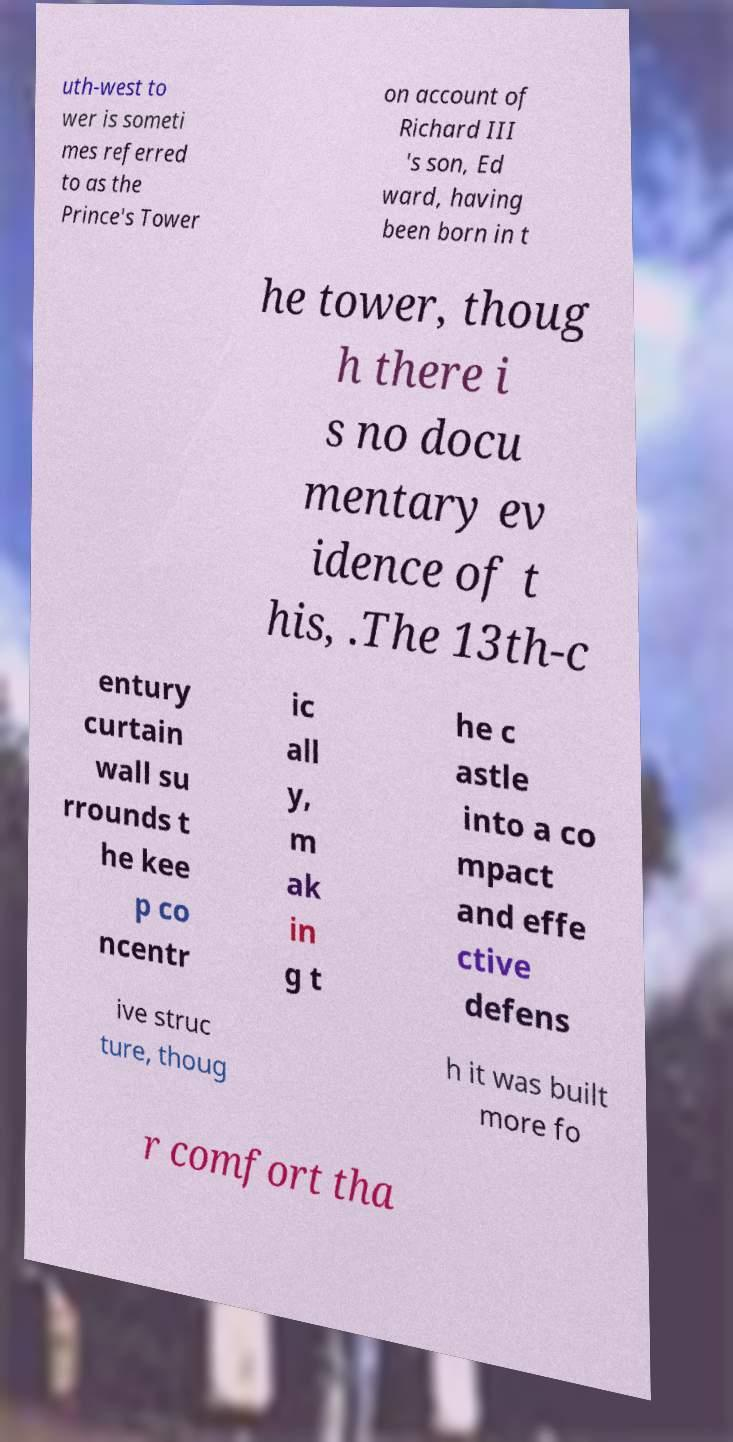What messages or text are displayed in this image? I need them in a readable, typed format. uth-west to wer is someti mes referred to as the Prince's Tower on account of Richard III 's son, Ed ward, having been born in t he tower, thoug h there i s no docu mentary ev idence of t his, .The 13th-c entury curtain wall su rrounds t he kee p co ncentr ic all y, m ak in g t he c astle into a co mpact and effe ctive defens ive struc ture, thoug h it was built more fo r comfort tha 